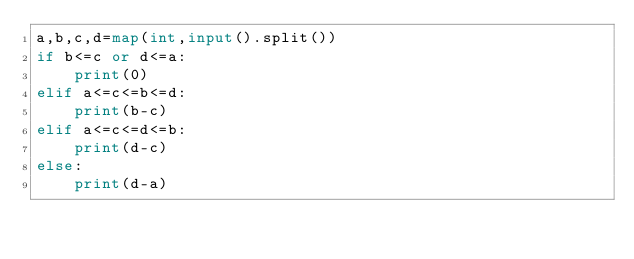<code> <loc_0><loc_0><loc_500><loc_500><_Python_>a,b,c,d=map(int,input().split())
if b<=c or d<=a:
    print(0)
elif a<=c<=b<=d:
    print(b-c)
elif a<=c<=d<=b:
    print(d-c)
else:
    print(d-a)</code> 